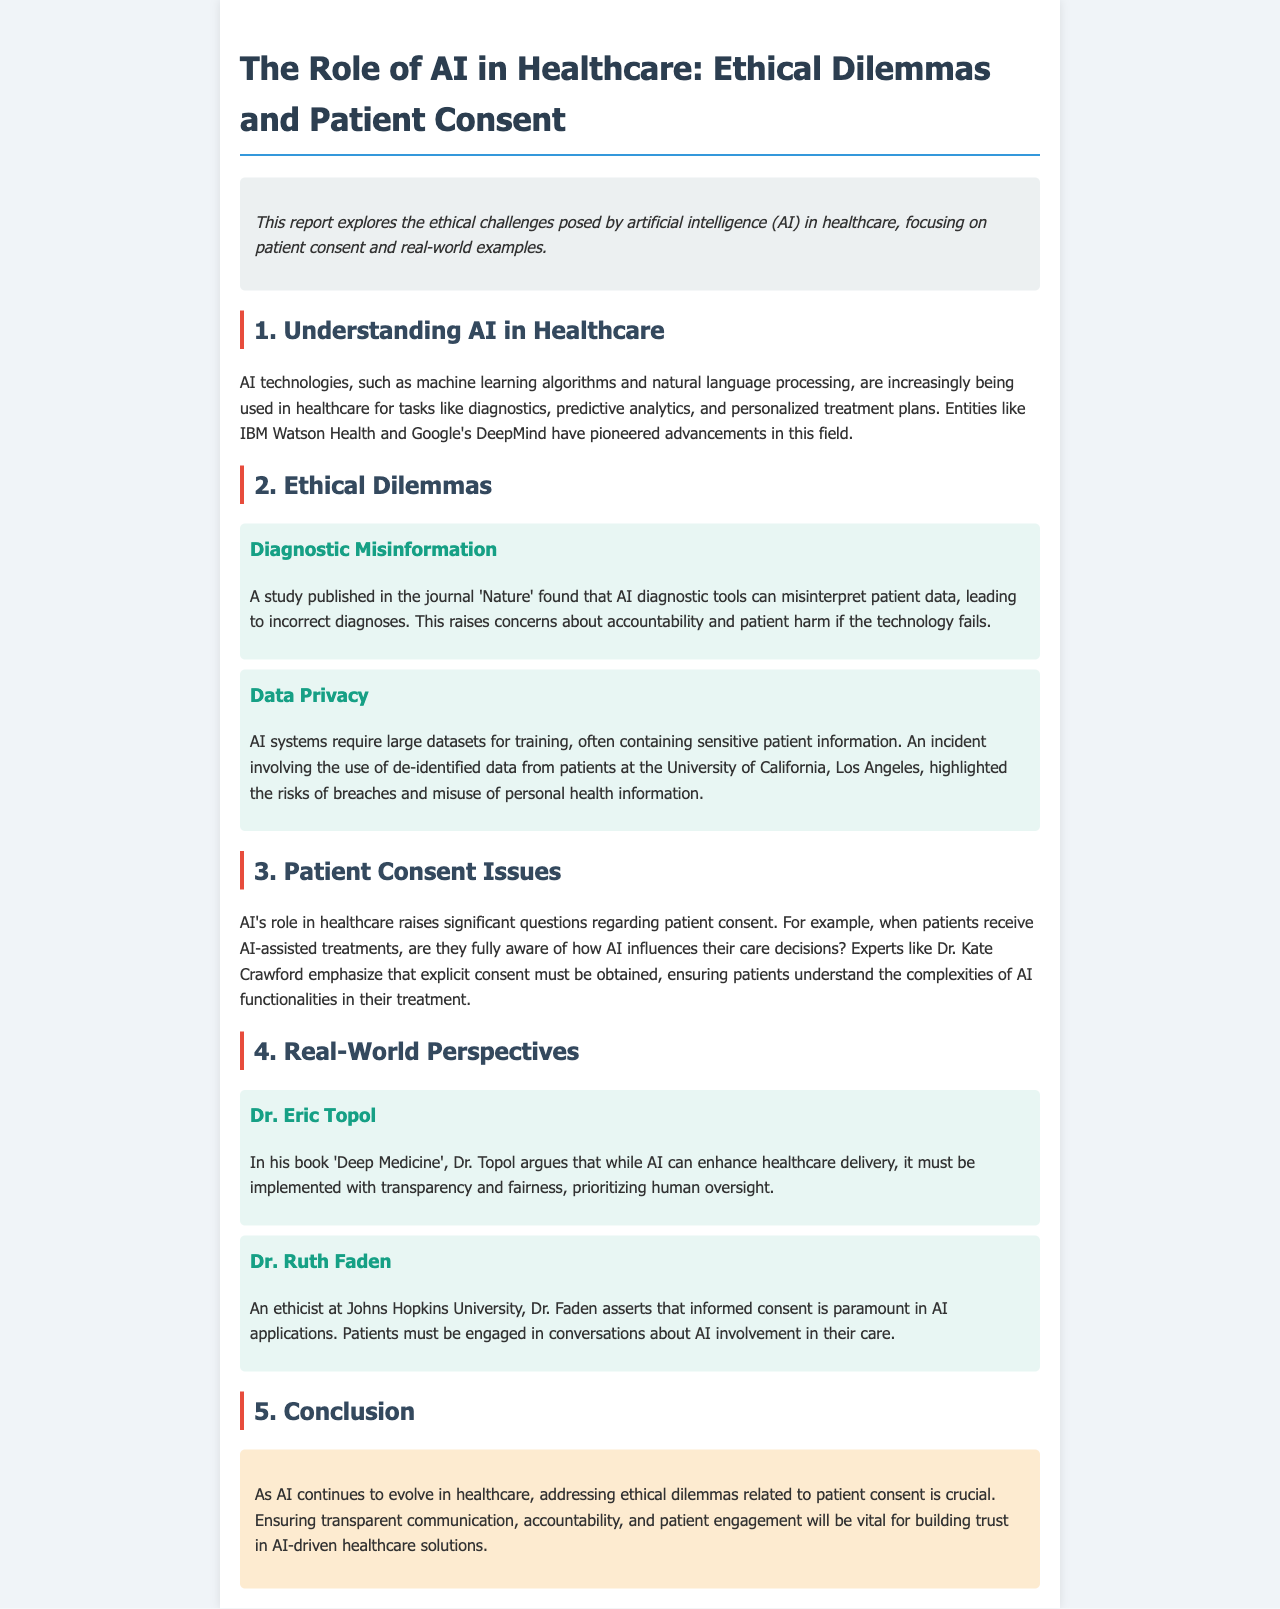What is the main focus of the report? The report explores the ethical challenges posed by artificial intelligence (AI) in healthcare, focusing on patient consent and real-world examples.
Answer: Ethical challenges posed by AI in healthcare Which entities have pioneered advancements in AI healthcare? The report mentions entities like IBM Watson Health and Google's DeepMind as pioneers in AI healthcare advancements.
Answer: IBM Watson Health and Google's DeepMind What ethical dilemma is associated with AI diagnostic tools? The document states that AI diagnostic tools can misinterpret patient data, leading to incorrect diagnoses, raising concerns about accountability and patient harm.
Answer: Diagnostic misinformation Who emphasizes the need for explicit consent regarding AI in healthcare? Dr. Kate Crawford is mentioned in the report as emphasizing the need for explicit consent from patients regarding AI involvement in their care.
Answer: Dr. Kate Crawford What does Dr. Eric Topol argue in 'Deep Medicine'? Dr. Topol argues that while AI can enhance healthcare delivery, it must be implemented with transparency and fairness, prioritizing human oversight.
Answer: Transparency and fairness What is paramount in AI applications according to Dr. Ruth Faden? Dr. Faden asserts that informed consent is paramount in AI applications, emphasizing the need for patient engagement in discussions about AI.
Answer: Informed consent What is the conclusion regarding AI in healthcare? The conclusion highlights the importance of addressing ethical dilemmas related to patient consent and ensuring transparent communication and patient engagement.
Answer: Addressing ethical dilemmas related to patient consent What type of patient information can AI systems require? The report states that AI systems require large datasets for training, often containing sensitive patient information.
Answer: Sensitive patient information 